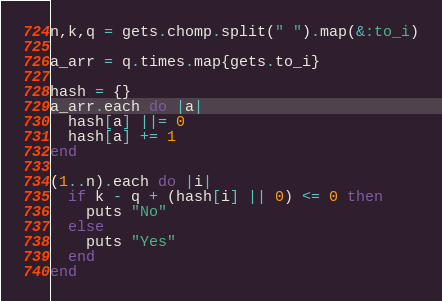<code> <loc_0><loc_0><loc_500><loc_500><_Ruby_>n,k,q = gets.chomp.split(" ").map(&:to_i)

a_arr = q.times.map{gets.to_i}

hash = {}
a_arr.each do |a|
  hash[a] ||= 0
  hash[a] += 1
end

(1..n).each do |i|
  if k - q + (hash[i] || 0) <= 0 then
    puts "No"
  else
    puts "Yes"
  end
end
</code> 